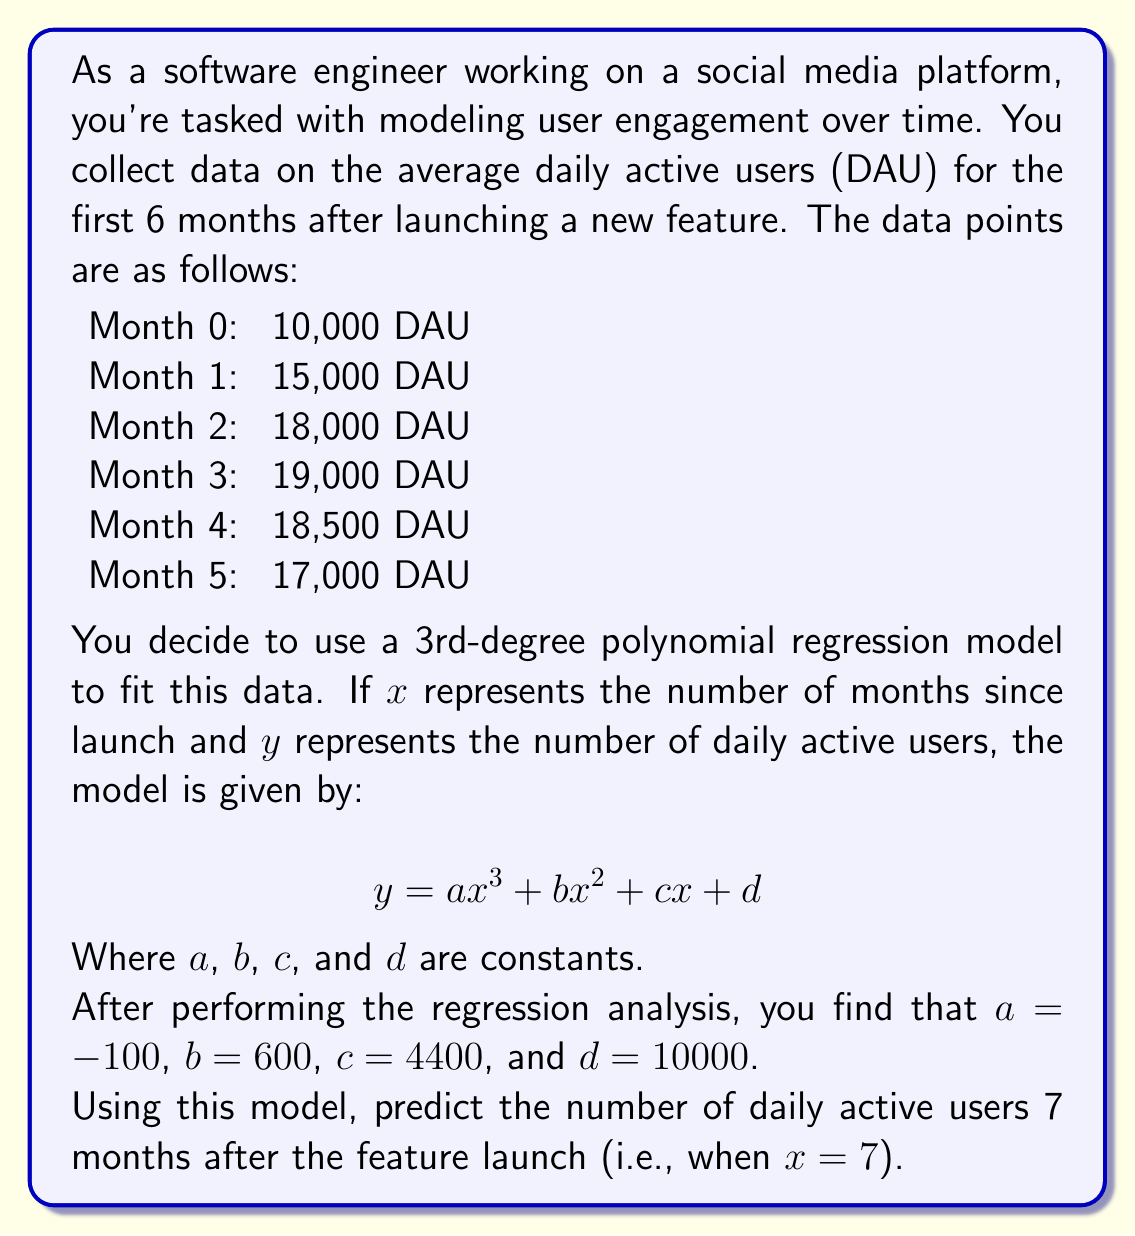Could you help me with this problem? To solve this problem, we need to follow these steps:

1. Understand the given polynomial regression model:
   $$ y = ax^3 + bx^2 + cx + d $$

2. Identify the values of the constants:
   $a = -100$
   $b = 600$
   $c = 4400$
   $d = 10000$

3. Substitute $x = 7$ into the equation, as we want to predict the DAU for the 7th month:
   $$ y = -100(7^3) + 600(7^2) + 4400(7) + 10000 $$

4. Calculate each term:
   $-100(7^3) = -100 \times 343 = -34300$
   $600(7^2) = 600 \times 49 = 29400$
   $4400(7) = 30800$
   $10000$ (constant term)

5. Sum up all the terms:
   $$ y = -34300 + 29400 + 30800 + 10000 $$

6. Compute the final result:
   $$ y = 35900 $$

Therefore, the model predicts 35,900 daily active users 7 months after the feature launch.
Answer: 35,900 daily active users 